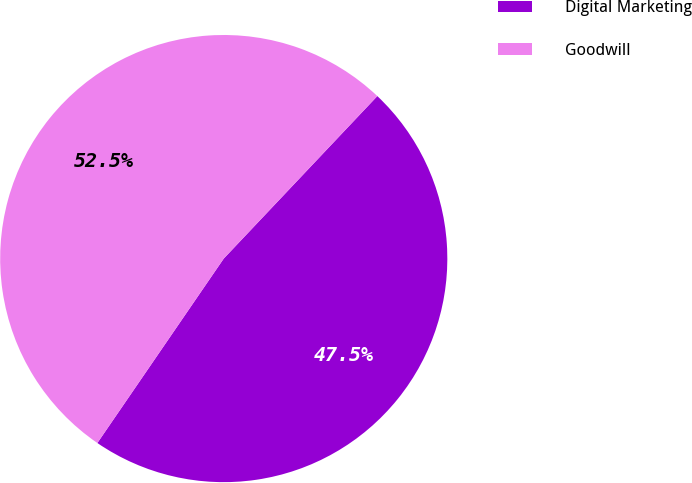Convert chart. <chart><loc_0><loc_0><loc_500><loc_500><pie_chart><fcel>Digital Marketing<fcel>Goodwill<nl><fcel>47.51%<fcel>52.49%<nl></chart> 